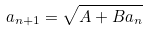<formula> <loc_0><loc_0><loc_500><loc_500>a _ { n + 1 } = \sqrt { A + B a _ { n } }</formula> 